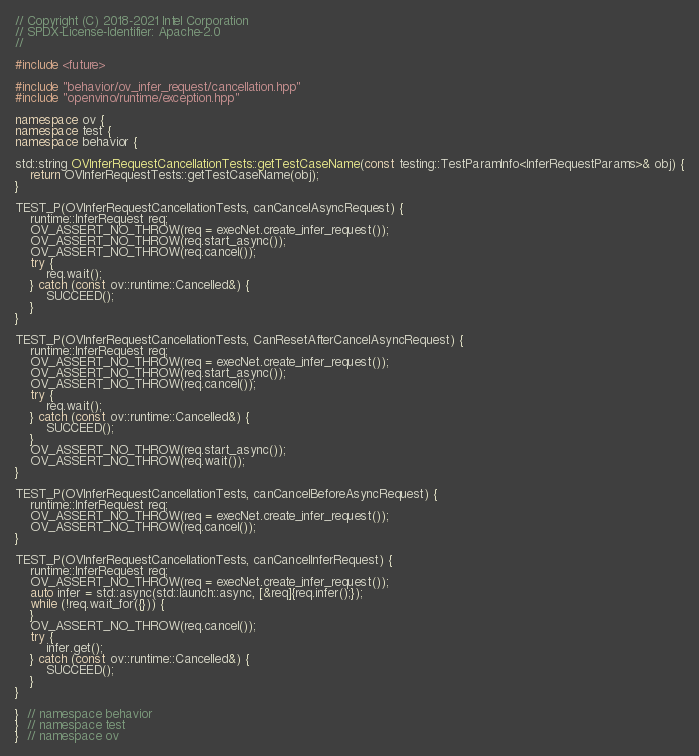<code> <loc_0><loc_0><loc_500><loc_500><_C++_>// Copyright (C) 2018-2021 Intel Corporation
// SPDX-License-Identifier: Apache-2.0
//

#include <future>

#include "behavior/ov_infer_request/cancellation.hpp"
#include "openvino/runtime/exception.hpp"

namespace ov {
namespace test {
namespace behavior {

std::string OVInferRequestCancellationTests::getTestCaseName(const testing::TestParamInfo<InferRequestParams>& obj) {
    return OVInferRequestTests::getTestCaseName(obj);
}

TEST_P(OVInferRequestCancellationTests, canCancelAsyncRequest) {
    runtime::InferRequest req;
    OV_ASSERT_NO_THROW(req = execNet.create_infer_request());
    OV_ASSERT_NO_THROW(req.start_async());
    OV_ASSERT_NO_THROW(req.cancel());
    try {
        req.wait();
    } catch (const ov::runtime::Cancelled&) {
        SUCCEED();
    }
}

TEST_P(OVInferRequestCancellationTests, CanResetAfterCancelAsyncRequest) {
    runtime::InferRequest req;
    OV_ASSERT_NO_THROW(req = execNet.create_infer_request());
    OV_ASSERT_NO_THROW(req.start_async());
    OV_ASSERT_NO_THROW(req.cancel());
    try {
        req.wait();
    } catch (const ov::runtime::Cancelled&) {
        SUCCEED();
    }
    OV_ASSERT_NO_THROW(req.start_async());
    OV_ASSERT_NO_THROW(req.wait());
}

TEST_P(OVInferRequestCancellationTests, canCancelBeforeAsyncRequest) {
    runtime::InferRequest req;
    OV_ASSERT_NO_THROW(req = execNet.create_infer_request());
    OV_ASSERT_NO_THROW(req.cancel());
}

TEST_P(OVInferRequestCancellationTests, canCancelInferRequest) {
    runtime::InferRequest req;
    OV_ASSERT_NO_THROW(req = execNet.create_infer_request());
    auto infer = std::async(std::launch::async, [&req]{req.infer();});
    while (!req.wait_for({})) {
    }
    OV_ASSERT_NO_THROW(req.cancel());
    try {
        infer.get();
    } catch (const ov::runtime::Cancelled&) {
        SUCCEED();
    }
}

}  // namespace behavior
}  // namespace test
}  // namespace ov
</code> 